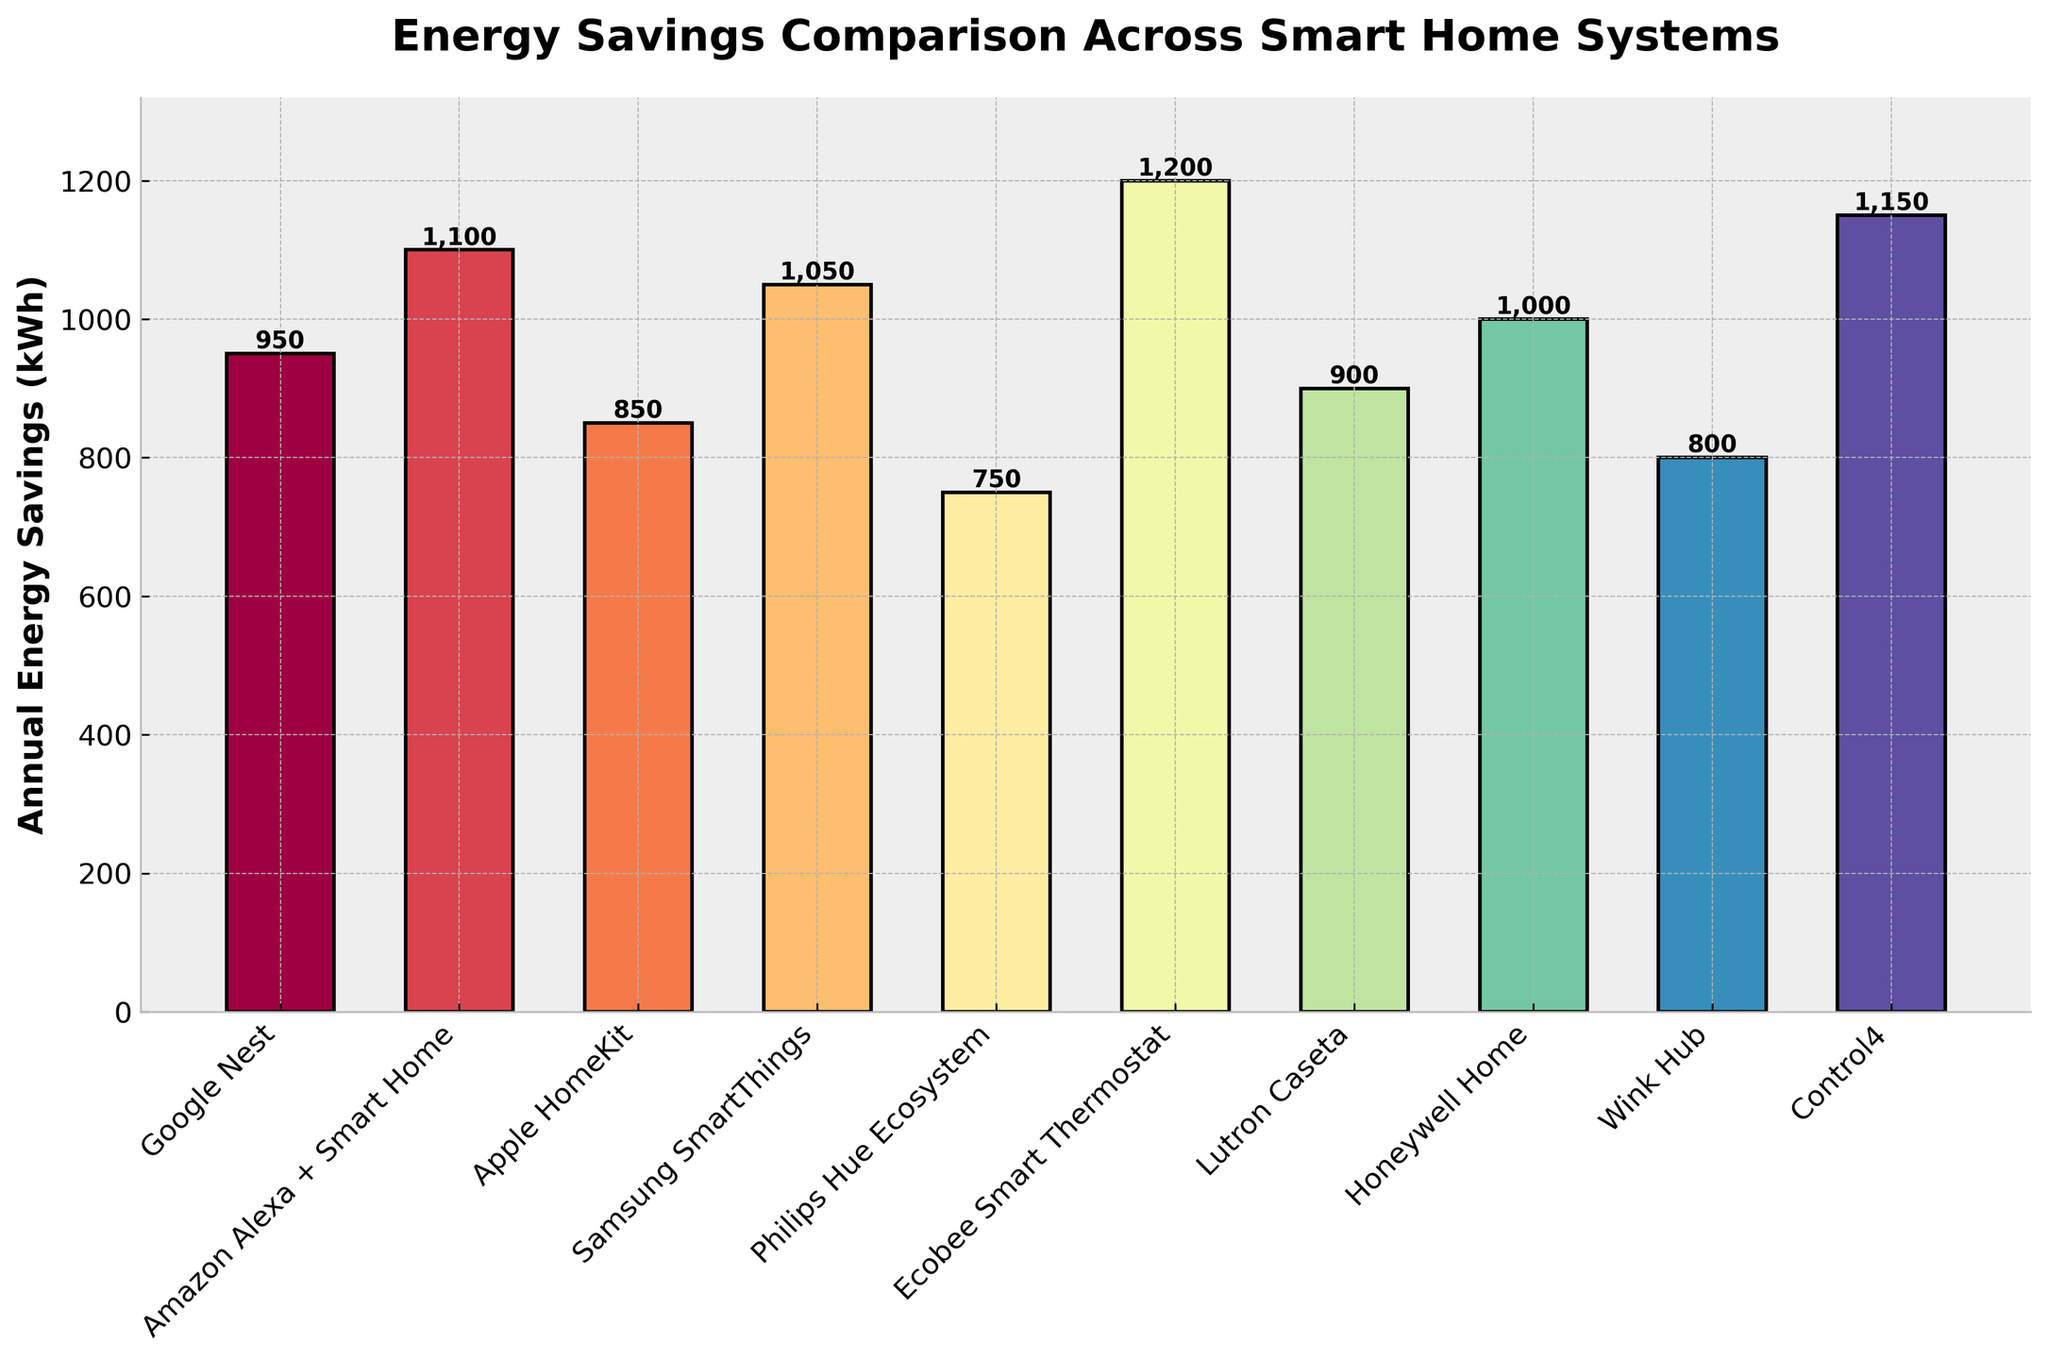What's the system with the highest annual energy savings? First, identify and compare the height of each bar in the chart. The tallest bar represents the system with the highest energy savings.
Answer: Ecobee Smart Thermostat What is the difference in annual energy savings between Amazon Alexa + Smart Home and Philips Hue Ecosystem? Look at the bars corresponding to Amazon Alexa + Smart Home and Philips Hue Ecosystem. Note their heights (1100 kWh and 750 kWh, respectively). Subtract the savings for Philips Hue from Amazon Alexa.
Answer: 350 kWh Which system shows the least annual energy savings and how much is it? Compare the height of all the bars to find the shortest one. The system with the shortest bar saves the least amount of energy annually. Identify its height from the figure.
Answer: Philips Hue Ecosystem, 750 kWh What's the average annual energy savings across all the smart home systems shown? Sum the energy savings of all systems: 950 (Google Nest) + 1100 (Amazon Alexa + Smart Home) + 850 (Apple HomeKit) + 1050 (Samsung SmartThings) + 750 (Philips Hue) + 1200 (Ecobee) + 900 (Lutron Caseta) + 1000 (Honeywell Home) + 800 (Wink Hub) + 1150 (Control4). Divide the total by the number of systems (10).
Answer: 975 kWh Which systems have energy savings greater than 1000 kWh annually? Identify and list out all the bars that have a height greater than 1000 kWh by referencing the y-axis values.
Answer: Amazon Alexa + Smart Home, Samsung SmartThings, Ecobee Smart Thermostat, Control4 How much more energy does the Honeywell Home system save compared to the Wink Hub? Find the heights of the bars for Honeywell Home (1000 kWh) and Wink Hub (800 kWh). Subtract Wink Hub's savings from Honeywell Home's.
Answer: 200 kWh Rank the systems with respect to their energy savings in descending order. Compare the heights of the bars and order them from tallest to shortest: Ecobee Smart Thermostat, Control4, Amazon Alexa + Smart Home, Samsung SmartThings, Honeywell Home, Google Nest, Lutron Caseta, Apple HomeKit, Wink Hub, Philips Hue Ecosystem.
Answer: Ecobee Smart Thermostat, Control4, Amazon Alexa + Smart Home, Samsung SmartThings, Honeywell Home, Google Nest, Lutron Caseta, Apple HomeKit, Wink Hub, Philips Hue Ecosystem What's the combined annual energy savings for Google Nest and Samsung SmartThings? Add the heights of the bars for Google Nest (950 kWh) and Samsung SmartThings (1050 kWh).
Answer: 2000 kWh Which system saves 100 kWh more annually than Google Nest? Find the height of the Google Nest bar (950 kWh) and look for a bar that is 100 kWh higher.
Answer: Samsung SmartThings How many systems save at least 900 kWh annually? Count the number of bars that are equal to or taller than 900 kWh. The systems are Google Nest, Amazon Alexa + Smart Home, Samsung SmartThings, Ecobee Smart Thermostat, Lutron Caseta, Honeywell Home, Control4.
Answer: 7 